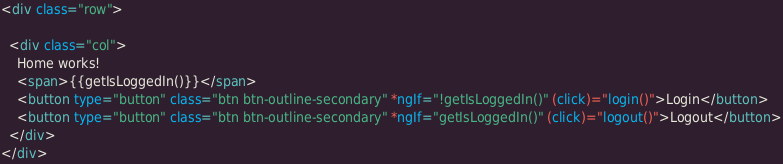<code> <loc_0><loc_0><loc_500><loc_500><_HTML_><div class="row">

  <div class="col">
    Home works!
    <span>{{getIsLoggedIn()}}</span>
    <button type="button" class="btn btn-outline-secondary" *ngIf="!getIsLoggedIn()" (click)="login()">Login</button>
    <button type="button" class="btn btn-outline-secondary" *ngIf="getIsLoggedIn()" (click)="logout()">Logout</button>
  </div>
</div>
</code> 